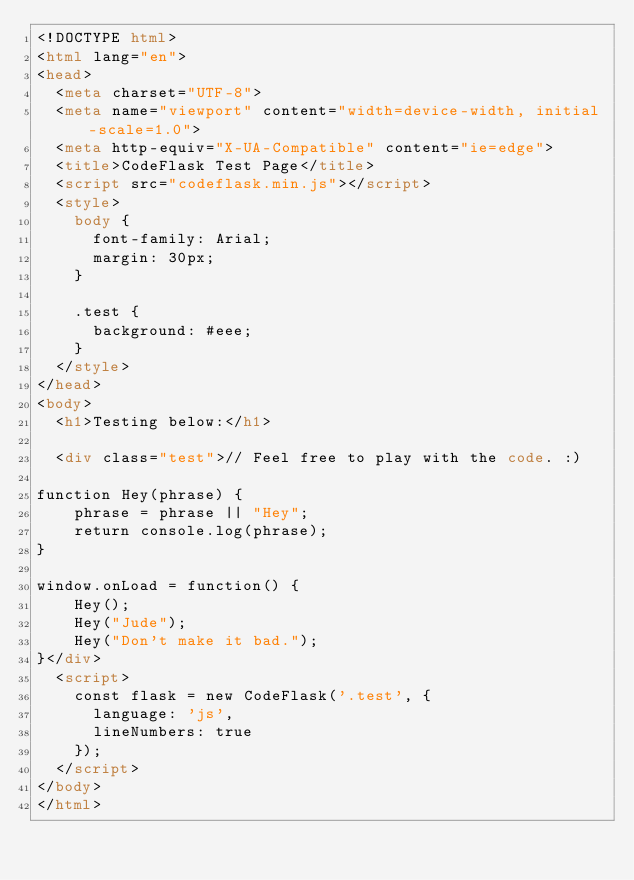Convert code to text. <code><loc_0><loc_0><loc_500><loc_500><_HTML_><!DOCTYPE html>
<html lang="en">
<head>
  <meta charset="UTF-8">
  <meta name="viewport" content="width=device-width, initial-scale=1.0">
  <meta http-equiv="X-UA-Compatible" content="ie=edge">
  <title>CodeFlask Test Page</title>
  <script src="codeflask.min.js"></script>
  <style>
    body {
      font-family: Arial;
      margin: 30px;
    }

    .test {
      background: #eee;
    }
  </style>
</head>
<body>
  <h1>Testing below:</h1>

  <div class="test">// Feel free to play with the code. :)

function Hey(phrase) {
    phrase = phrase || "Hey";
    return console.log(phrase);
}

window.onLoad = function() {
    Hey();
    Hey("Jude");
    Hey("Don't make it bad.");
}</div>
  <script>
    const flask = new CodeFlask('.test', {
      language: 'js',
      lineNumbers: true
    });
  </script>
</body>
</html></code> 